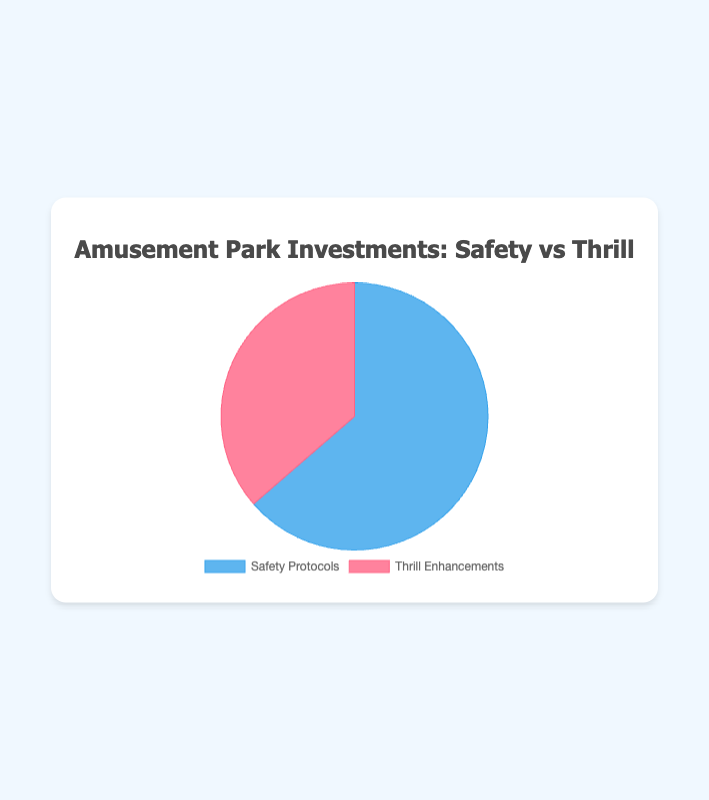What is the percentage of investments dedicated to Safety Protocols? To determine the percentage, we first find the total investment in both Safety Protocols and Thrill Enhancements. The total for Safety Protocols is 15 + 10 + 20 + 10 + 15 = 70. The total for Thrill Enhancements is 18 + 10 + 12 = 40. The total investment is 70 + 40 = 110. The percentage for Safety Protocols is (70 / 110) * 100 ≈ 63.64%.
Answer: 63.64% What is the percentage of investments dedicated to Thrill Enhancements? To find the percentage for Thrill Enhancements, we use the same total investment values. The percentage for Thrill Enhancements is (40 / 110) * 100 ≈ 36.36%.
Answer: 36.36% Which category has a higher investment, Safety Protocols or Thrill Enhancements? By comparing the totals directly, Safety Protocols have a total investment of 70, whereas Thrill Enhancements have a total investment of 40. Hence, Safety Protocols have higher investment.
Answer: Safety Protocols How much more is invested in Safety Protocols compared to Thrill Enhancements? The difference in investment is the total for Safety Protocols minus the total for Thrill Enhancements. That is 70 - 40 = 30.
Answer: 30 By what factor is the investment in Regular Maintenance greater than the investment in Ride Speed Enhancements? The investment in Regular Maintenance is 20, and the investment in Ride Speed Enhancements is 10. The factor is 20 / 10 = 2.
Answer: 2 What is the total investment in safety inspections and fire safety measures combined? The investment in Safety Inspections is 15 and in Fire Safety Measures is also 15. Therefore, the combined investment is 15 + 15 = 30.
Answer: 30 What portion of the investment in Safety Protocols is dedicated to Fire Safety Measures? To find this, we calculate the percentage of Fire Safety Measures within Safety Protocols. The investment in Fire Safety Measures is 15 out of a total of 70 in Safety Protocols, thus the portion is (15 / 70) * 100 ≈ 21.43%.
Answer: 21.43% 